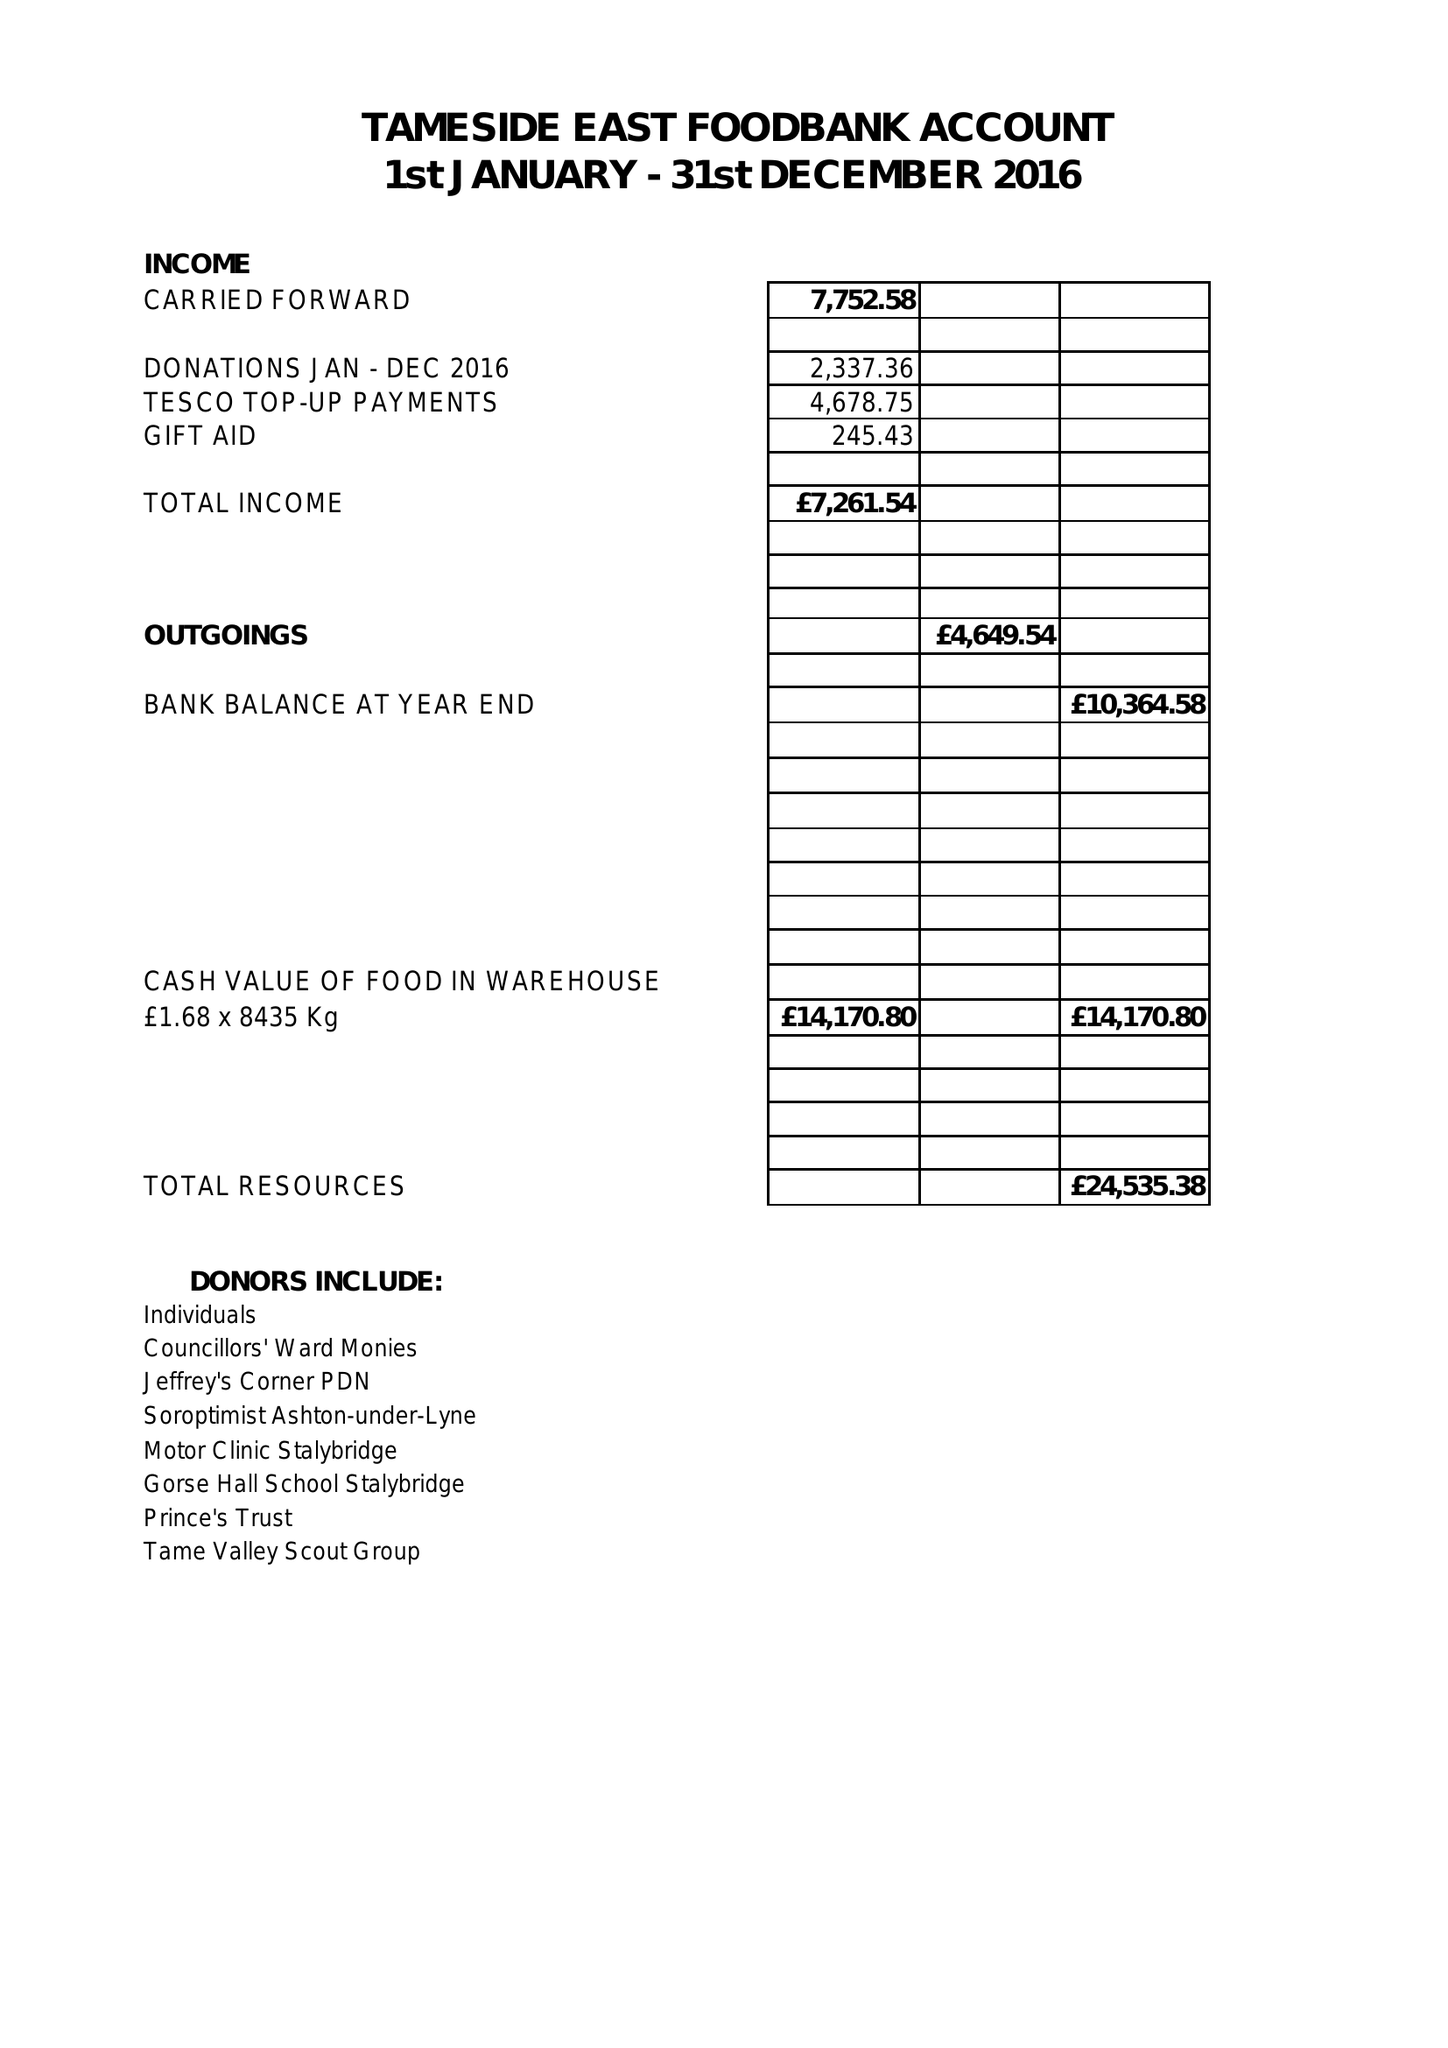What is the value for the report_date?
Answer the question using a single word or phrase. 2016-12-31 